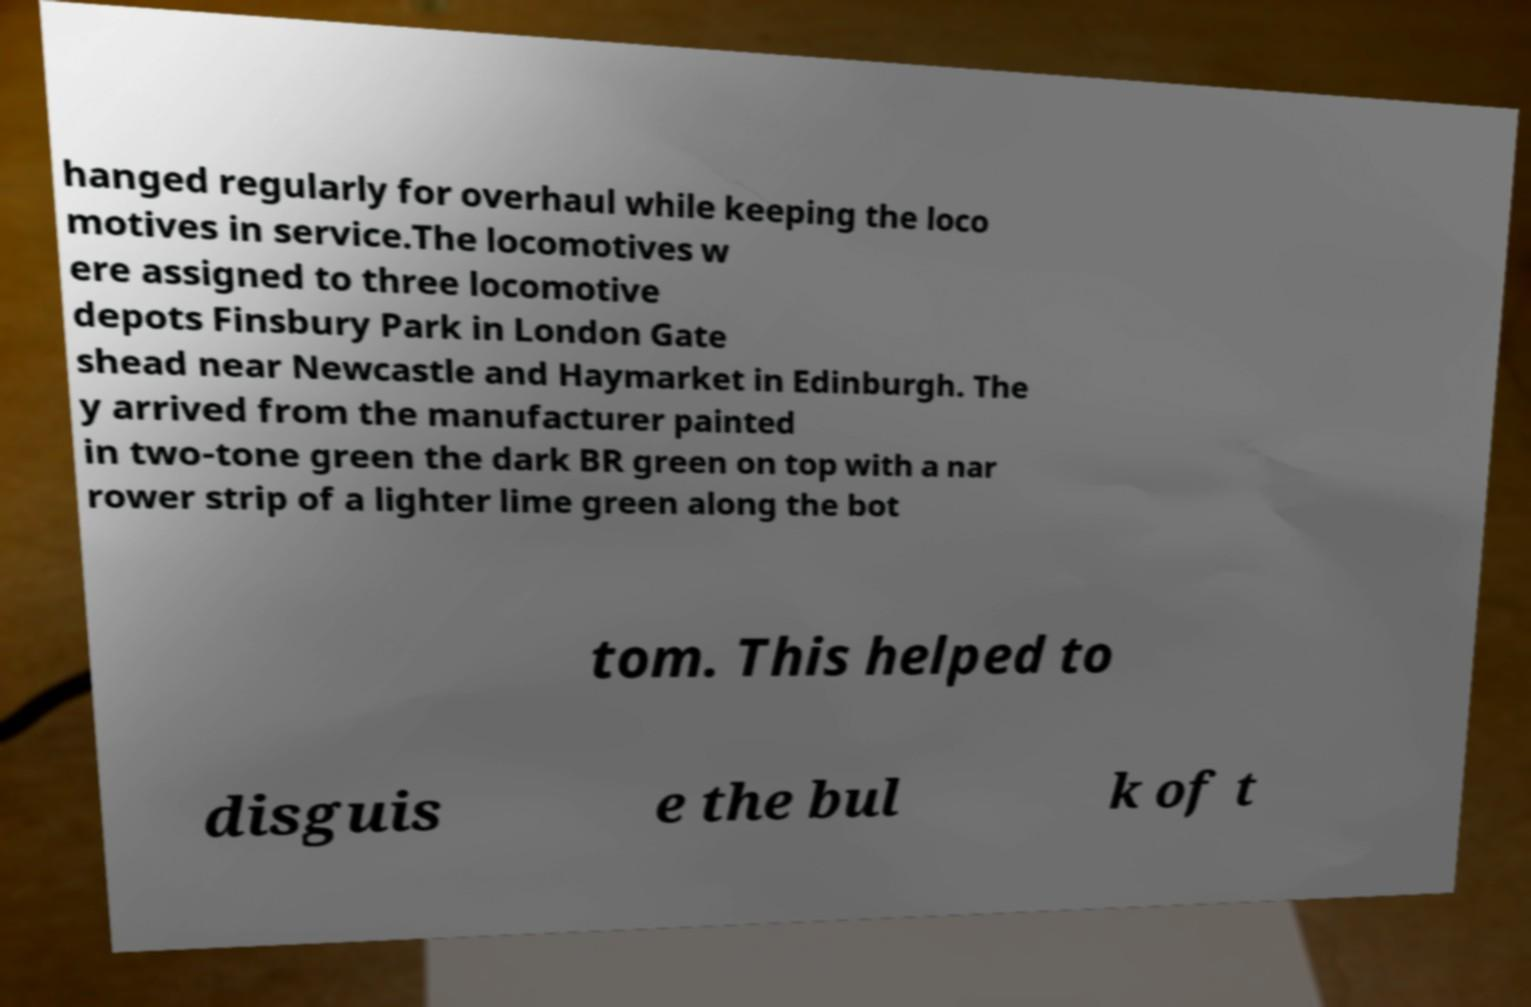For documentation purposes, I need the text within this image transcribed. Could you provide that? hanged regularly for overhaul while keeping the loco motives in service.The locomotives w ere assigned to three locomotive depots Finsbury Park in London Gate shead near Newcastle and Haymarket in Edinburgh. The y arrived from the manufacturer painted in two-tone green the dark BR green on top with a nar rower strip of a lighter lime green along the bot tom. This helped to disguis e the bul k of t 